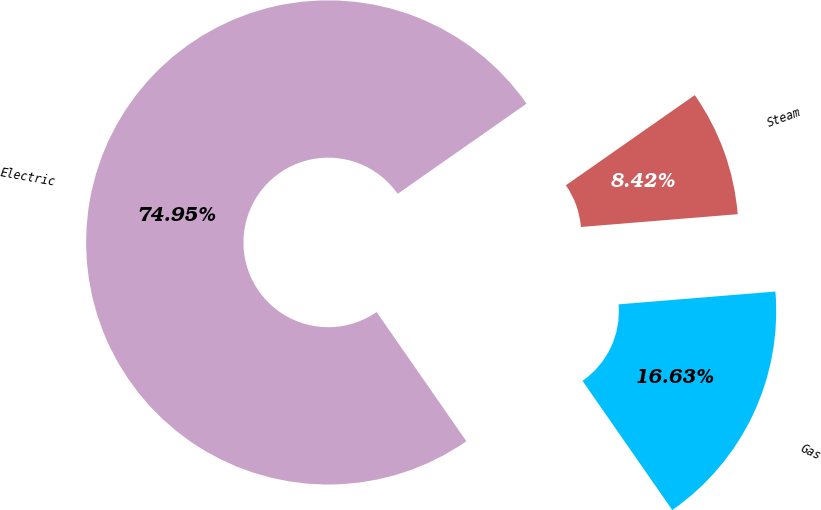Convert chart. <chart><loc_0><loc_0><loc_500><loc_500><pie_chart><fcel>Electric<fcel>Gas<fcel>Steam<nl><fcel>74.95%<fcel>16.63%<fcel>8.42%<nl></chart> 